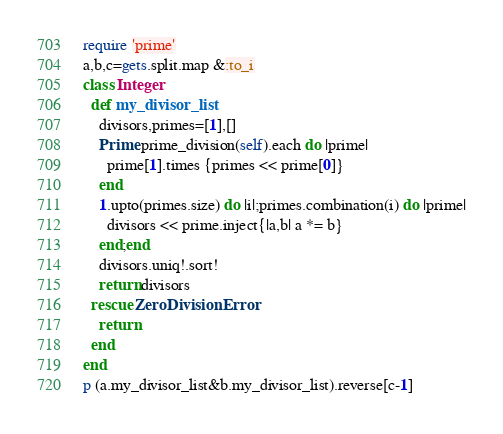<code> <loc_0><loc_0><loc_500><loc_500><_Ruby_>require 'prime'
a,b,c=gets.split.map &:to_i
class Integer
  def my_divisor_list
    divisors,primes=[1],[]
    Prime.prime_division(self).each do |prime|
      prime[1].times {primes << prime[0]}
    end
    1.upto(primes.size) do |i|;primes.combination(i) do |prime|
      divisors << prime.inject{|a,b| a *= b}
    end;end
    divisors.uniq!.sort!
    return divisors
  rescue ZeroDivisionError
    return
  end
end
p (a.my_divisor_list&b.my_divisor_list).reverse[c-1]</code> 